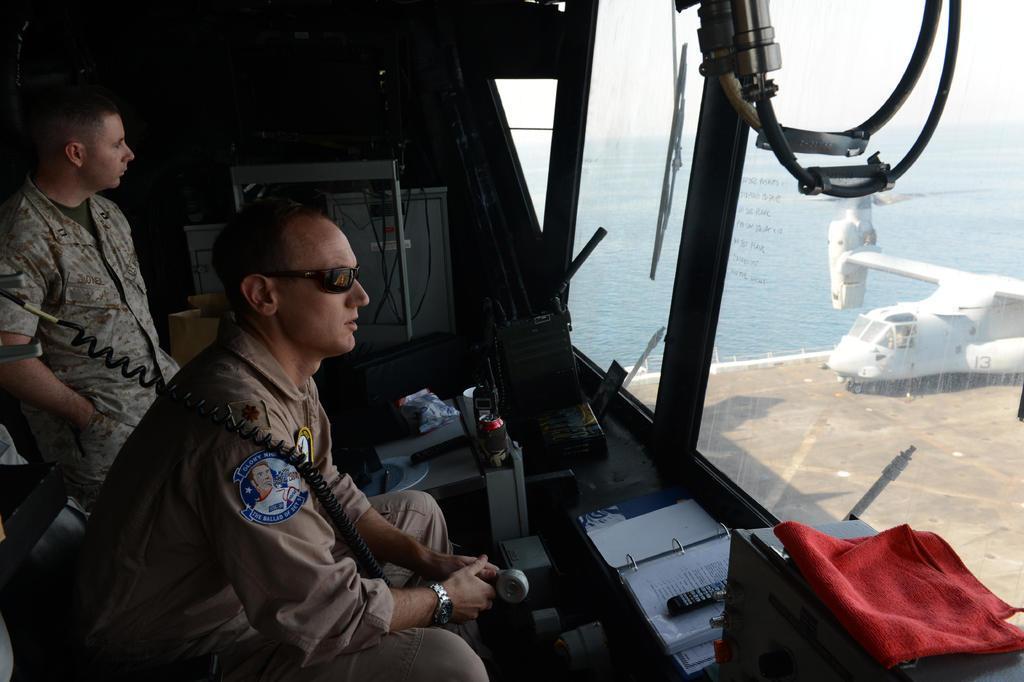Could you give a brief overview of what you see in this image? As we can see in the image there is water, plane, books, remote, cloth, phone and two people wearing army dresses. 